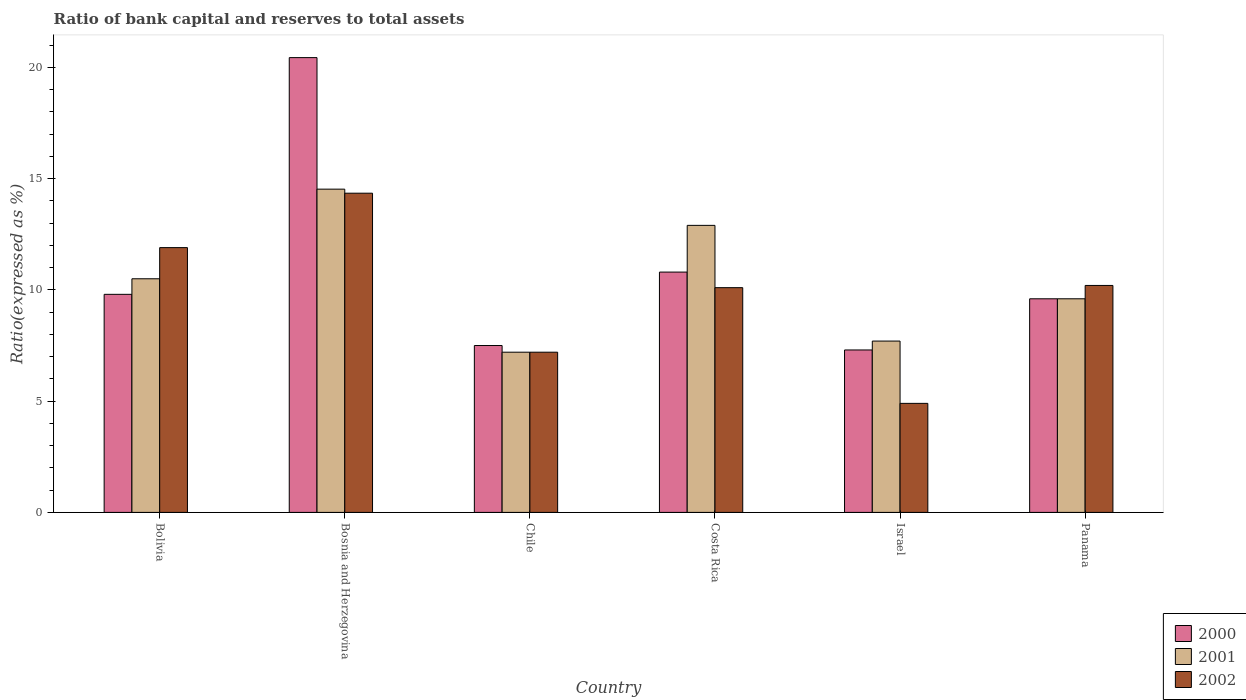How many different coloured bars are there?
Keep it short and to the point. 3. How many groups of bars are there?
Give a very brief answer. 6. Are the number of bars on each tick of the X-axis equal?
Offer a terse response. Yes. How many bars are there on the 1st tick from the left?
Provide a succinct answer. 3. How many bars are there on the 3rd tick from the right?
Offer a very short reply. 3. What is the label of the 6th group of bars from the left?
Your answer should be very brief. Panama. In how many cases, is the number of bars for a given country not equal to the number of legend labels?
Your answer should be compact. 0. What is the ratio of bank capital and reserves to total assets in 2000 in Bosnia and Herzegovina?
Offer a terse response. 20.44. Across all countries, what is the maximum ratio of bank capital and reserves to total assets in 2002?
Offer a very short reply. 14.35. Across all countries, what is the minimum ratio of bank capital and reserves to total assets in 2000?
Give a very brief answer. 7.3. In which country was the ratio of bank capital and reserves to total assets in 2001 maximum?
Offer a very short reply. Bosnia and Herzegovina. In which country was the ratio of bank capital and reserves to total assets in 2002 minimum?
Make the answer very short. Israel. What is the total ratio of bank capital and reserves to total assets in 2001 in the graph?
Offer a terse response. 62.43. What is the difference between the ratio of bank capital and reserves to total assets in 2002 in Bosnia and Herzegovina and that in Israel?
Your response must be concise. 9.45. What is the difference between the ratio of bank capital and reserves to total assets in 2002 in Chile and the ratio of bank capital and reserves to total assets in 2000 in Panama?
Provide a succinct answer. -2.4. What is the average ratio of bank capital and reserves to total assets in 2002 per country?
Your answer should be compact. 9.77. What is the difference between the ratio of bank capital and reserves to total assets of/in 2000 and ratio of bank capital and reserves to total assets of/in 2002 in Bolivia?
Your answer should be compact. -2.1. In how many countries, is the ratio of bank capital and reserves to total assets in 2002 greater than 18 %?
Your answer should be very brief. 0. What is the ratio of the ratio of bank capital and reserves to total assets in 2002 in Israel to that in Panama?
Ensure brevity in your answer.  0.48. Is the difference between the ratio of bank capital and reserves to total assets in 2000 in Bolivia and Chile greater than the difference between the ratio of bank capital and reserves to total assets in 2002 in Bolivia and Chile?
Keep it short and to the point. No. What is the difference between the highest and the second highest ratio of bank capital and reserves to total assets in 2002?
Make the answer very short. -1.7. What is the difference between the highest and the lowest ratio of bank capital and reserves to total assets in 2000?
Offer a very short reply. 13.14. What does the 2nd bar from the left in Bolivia represents?
Make the answer very short. 2001. How many bars are there?
Your answer should be compact. 18. Are all the bars in the graph horizontal?
Provide a short and direct response. No. How many countries are there in the graph?
Your answer should be compact. 6. Are the values on the major ticks of Y-axis written in scientific E-notation?
Your response must be concise. No. Does the graph contain any zero values?
Offer a very short reply. No. Where does the legend appear in the graph?
Provide a succinct answer. Bottom right. How are the legend labels stacked?
Offer a terse response. Vertical. What is the title of the graph?
Provide a short and direct response. Ratio of bank capital and reserves to total assets. Does "1971" appear as one of the legend labels in the graph?
Give a very brief answer. No. What is the label or title of the Y-axis?
Give a very brief answer. Ratio(expressed as %). What is the Ratio(expressed as %) in 2001 in Bolivia?
Keep it short and to the point. 10.5. What is the Ratio(expressed as %) in 2002 in Bolivia?
Your response must be concise. 11.9. What is the Ratio(expressed as %) in 2000 in Bosnia and Herzegovina?
Keep it short and to the point. 20.44. What is the Ratio(expressed as %) of 2001 in Bosnia and Herzegovina?
Give a very brief answer. 14.53. What is the Ratio(expressed as %) of 2002 in Bosnia and Herzegovina?
Keep it short and to the point. 14.35. What is the Ratio(expressed as %) of 2001 in Chile?
Make the answer very short. 7.2. What is the Ratio(expressed as %) of 2000 in Costa Rica?
Offer a terse response. 10.8. What is the Ratio(expressed as %) of 2001 in Costa Rica?
Provide a succinct answer. 12.9. What is the Ratio(expressed as %) of 2000 in Israel?
Ensure brevity in your answer.  7.3. What is the Ratio(expressed as %) in 2002 in Israel?
Ensure brevity in your answer.  4.9. What is the Ratio(expressed as %) in 2000 in Panama?
Offer a very short reply. 9.6. Across all countries, what is the maximum Ratio(expressed as %) in 2000?
Provide a short and direct response. 20.44. Across all countries, what is the maximum Ratio(expressed as %) of 2001?
Provide a short and direct response. 14.53. Across all countries, what is the maximum Ratio(expressed as %) in 2002?
Offer a very short reply. 14.35. Across all countries, what is the minimum Ratio(expressed as %) in 2001?
Provide a succinct answer. 7.2. What is the total Ratio(expressed as %) in 2000 in the graph?
Provide a short and direct response. 65.44. What is the total Ratio(expressed as %) in 2001 in the graph?
Your answer should be compact. 62.43. What is the total Ratio(expressed as %) in 2002 in the graph?
Ensure brevity in your answer.  58.65. What is the difference between the Ratio(expressed as %) in 2000 in Bolivia and that in Bosnia and Herzegovina?
Offer a terse response. -10.64. What is the difference between the Ratio(expressed as %) in 2001 in Bolivia and that in Bosnia and Herzegovina?
Ensure brevity in your answer.  -4.03. What is the difference between the Ratio(expressed as %) in 2002 in Bolivia and that in Bosnia and Herzegovina?
Your answer should be compact. -2.45. What is the difference between the Ratio(expressed as %) of 2001 in Bolivia and that in Chile?
Offer a terse response. 3.3. What is the difference between the Ratio(expressed as %) in 2002 in Bolivia and that in Chile?
Your response must be concise. 4.7. What is the difference between the Ratio(expressed as %) in 2001 in Bolivia and that in Costa Rica?
Provide a short and direct response. -2.4. What is the difference between the Ratio(expressed as %) of 2002 in Bolivia and that in Costa Rica?
Your response must be concise. 1.8. What is the difference between the Ratio(expressed as %) of 2000 in Bolivia and that in Israel?
Your response must be concise. 2.5. What is the difference between the Ratio(expressed as %) in 2001 in Bolivia and that in Israel?
Ensure brevity in your answer.  2.8. What is the difference between the Ratio(expressed as %) of 2001 in Bolivia and that in Panama?
Give a very brief answer. 0.9. What is the difference between the Ratio(expressed as %) of 2000 in Bosnia and Herzegovina and that in Chile?
Your response must be concise. 12.94. What is the difference between the Ratio(expressed as %) of 2001 in Bosnia and Herzegovina and that in Chile?
Keep it short and to the point. 7.33. What is the difference between the Ratio(expressed as %) in 2002 in Bosnia and Herzegovina and that in Chile?
Give a very brief answer. 7.15. What is the difference between the Ratio(expressed as %) in 2000 in Bosnia and Herzegovina and that in Costa Rica?
Your response must be concise. 9.64. What is the difference between the Ratio(expressed as %) of 2001 in Bosnia and Herzegovina and that in Costa Rica?
Ensure brevity in your answer.  1.63. What is the difference between the Ratio(expressed as %) of 2002 in Bosnia and Herzegovina and that in Costa Rica?
Provide a short and direct response. 4.25. What is the difference between the Ratio(expressed as %) of 2000 in Bosnia and Herzegovina and that in Israel?
Give a very brief answer. 13.14. What is the difference between the Ratio(expressed as %) of 2001 in Bosnia and Herzegovina and that in Israel?
Offer a very short reply. 6.83. What is the difference between the Ratio(expressed as %) in 2002 in Bosnia and Herzegovina and that in Israel?
Make the answer very short. 9.45. What is the difference between the Ratio(expressed as %) of 2000 in Bosnia and Herzegovina and that in Panama?
Make the answer very short. 10.84. What is the difference between the Ratio(expressed as %) of 2001 in Bosnia and Herzegovina and that in Panama?
Ensure brevity in your answer.  4.93. What is the difference between the Ratio(expressed as %) in 2002 in Bosnia and Herzegovina and that in Panama?
Offer a very short reply. 4.15. What is the difference between the Ratio(expressed as %) of 2000 in Chile and that in Costa Rica?
Give a very brief answer. -3.3. What is the difference between the Ratio(expressed as %) of 2002 in Chile and that in Costa Rica?
Give a very brief answer. -2.9. What is the difference between the Ratio(expressed as %) of 2000 in Chile and that in Israel?
Your answer should be compact. 0.2. What is the difference between the Ratio(expressed as %) in 2002 in Costa Rica and that in Israel?
Give a very brief answer. 5.2. What is the difference between the Ratio(expressed as %) in 2000 in Costa Rica and that in Panama?
Make the answer very short. 1.2. What is the difference between the Ratio(expressed as %) of 2000 in Israel and that in Panama?
Your answer should be very brief. -2.3. What is the difference between the Ratio(expressed as %) in 2001 in Israel and that in Panama?
Provide a succinct answer. -1.9. What is the difference between the Ratio(expressed as %) of 2000 in Bolivia and the Ratio(expressed as %) of 2001 in Bosnia and Herzegovina?
Offer a terse response. -4.73. What is the difference between the Ratio(expressed as %) in 2000 in Bolivia and the Ratio(expressed as %) in 2002 in Bosnia and Herzegovina?
Your answer should be compact. -4.55. What is the difference between the Ratio(expressed as %) in 2001 in Bolivia and the Ratio(expressed as %) in 2002 in Bosnia and Herzegovina?
Provide a short and direct response. -3.85. What is the difference between the Ratio(expressed as %) in 2001 in Bolivia and the Ratio(expressed as %) in 2002 in Chile?
Your response must be concise. 3.3. What is the difference between the Ratio(expressed as %) in 2000 in Bolivia and the Ratio(expressed as %) in 2001 in Costa Rica?
Give a very brief answer. -3.1. What is the difference between the Ratio(expressed as %) of 2000 in Bolivia and the Ratio(expressed as %) of 2002 in Costa Rica?
Offer a very short reply. -0.3. What is the difference between the Ratio(expressed as %) of 2001 in Bolivia and the Ratio(expressed as %) of 2002 in Costa Rica?
Ensure brevity in your answer.  0.4. What is the difference between the Ratio(expressed as %) of 2000 in Bolivia and the Ratio(expressed as %) of 2002 in Panama?
Provide a succinct answer. -0.4. What is the difference between the Ratio(expressed as %) in 2001 in Bolivia and the Ratio(expressed as %) in 2002 in Panama?
Ensure brevity in your answer.  0.3. What is the difference between the Ratio(expressed as %) in 2000 in Bosnia and Herzegovina and the Ratio(expressed as %) in 2001 in Chile?
Provide a succinct answer. 13.24. What is the difference between the Ratio(expressed as %) of 2000 in Bosnia and Herzegovina and the Ratio(expressed as %) of 2002 in Chile?
Make the answer very short. 13.24. What is the difference between the Ratio(expressed as %) in 2001 in Bosnia and Herzegovina and the Ratio(expressed as %) in 2002 in Chile?
Provide a succinct answer. 7.33. What is the difference between the Ratio(expressed as %) of 2000 in Bosnia and Herzegovina and the Ratio(expressed as %) of 2001 in Costa Rica?
Offer a terse response. 7.54. What is the difference between the Ratio(expressed as %) in 2000 in Bosnia and Herzegovina and the Ratio(expressed as %) in 2002 in Costa Rica?
Give a very brief answer. 10.34. What is the difference between the Ratio(expressed as %) in 2001 in Bosnia and Herzegovina and the Ratio(expressed as %) in 2002 in Costa Rica?
Make the answer very short. 4.43. What is the difference between the Ratio(expressed as %) of 2000 in Bosnia and Herzegovina and the Ratio(expressed as %) of 2001 in Israel?
Provide a short and direct response. 12.74. What is the difference between the Ratio(expressed as %) of 2000 in Bosnia and Herzegovina and the Ratio(expressed as %) of 2002 in Israel?
Offer a terse response. 15.54. What is the difference between the Ratio(expressed as %) in 2001 in Bosnia and Herzegovina and the Ratio(expressed as %) in 2002 in Israel?
Ensure brevity in your answer.  9.63. What is the difference between the Ratio(expressed as %) in 2000 in Bosnia and Herzegovina and the Ratio(expressed as %) in 2001 in Panama?
Your answer should be very brief. 10.84. What is the difference between the Ratio(expressed as %) of 2000 in Bosnia and Herzegovina and the Ratio(expressed as %) of 2002 in Panama?
Give a very brief answer. 10.24. What is the difference between the Ratio(expressed as %) of 2001 in Bosnia and Herzegovina and the Ratio(expressed as %) of 2002 in Panama?
Offer a terse response. 4.33. What is the difference between the Ratio(expressed as %) in 2000 in Chile and the Ratio(expressed as %) in 2002 in Costa Rica?
Offer a terse response. -2.6. What is the difference between the Ratio(expressed as %) of 2001 in Chile and the Ratio(expressed as %) of 2002 in Costa Rica?
Your answer should be very brief. -2.9. What is the difference between the Ratio(expressed as %) of 2000 in Chile and the Ratio(expressed as %) of 2001 in Israel?
Give a very brief answer. -0.2. What is the difference between the Ratio(expressed as %) in 2000 in Chile and the Ratio(expressed as %) in 2002 in Israel?
Give a very brief answer. 2.6. What is the difference between the Ratio(expressed as %) in 2001 in Chile and the Ratio(expressed as %) in 2002 in Israel?
Your response must be concise. 2.3. What is the difference between the Ratio(expressed as %) of 2000 in Chile and the Ratio(expressed as %) of 2002 in Panama?
Your response must be concise. -2.7. What is the difference between the Ratio(expressed as %) of 2001 in Chile and the Ratio(expressed as %) of 2002 in Panama?
Give a very brief answer. -3. What is the difference between the Ratio(expressed as %) of 2000 in Costa Rica and the Ratio(expressed as %) of 2001 in Israel?
Provide a short and direct response. 3.1. What is the difference between the Ratio(expressed as %) in 2001 in Costa Rica and the Ratio(expressed as %) in 2002 in Israel?
Keep it short and to the point. 8. What is the difference between the Ratio(expressed as %) of 2001 in Costa Rica and the Ratio(expressed as %) of 2002 in Panama?
Provide a succinct answer. 2.7. What is the difference between the Ratio(expressed as %) of 2000 in Israel and the Ratio(expressed as %) of 2001 in Panama?
Provide a succinct answer. -2.3. What is the average Ratio(expressed as %) of 2000 per country?
Make the answer very short. 10.91. What is the average Ratio(expressed as %) of 2001 per country?
Make the answer very short. 10.4. What is the average Ratio(expressed as %) of 2002 per country?
Ensure brevity in your answer.  9.77. What is the difference between the Ratio(expressed as %) of 2000 and Ratio(expressed as %) of 2001 in Bolivia?
Offer a very short reply. -0.7. What is the difference between the Ratio(expressed as %) of 2000 and Ratio(expressed as %) of 2001 in Bosnia and Herzegovina?
Your answer should be very brief. 5.91. What is the difference between the Ratio(expressed as %) of 2000 and Ratio(expressed as %) of 2002 in Bosnia and Herzegovina?
Ensure brevity in your answer.  6.09. What is the difference between the Ratio(expressed as %) in 2001 and Ratio(expressed as %) in 2002 in Bosnia and Herzegovina?
Your response must be concise. 0.18. What is the difference between the Ratio(expressed as %) in 2000 and Ratio(expressed as %) in 2001 in Chile?
Keep it short and to the point. 0.3. What is the difference between the Ratio(expressed as %) of 2000 and Ratio(expressed as %) of 2002 in Chile?
Your answer should be very brief. 0.3. What is the difference between the Ratio(expressed as %) of 2000 and Ratio(expressed as %) of 2002 in Costa Rica?
Provide a short and direct response. 0.7. What is the difference between the Ratio(expressed as %) of 2000 and Ratio(expressed as %) of 2001 in Israel?
Keep it short and to the point. -0.4. What is the difference between the Ratio(expressed as %) in 2000 and Ratio(expressed as %) in 2002 in Israel?
Your answer should be very brief. 2.4. What is the difference between the Ratio(expressed as %) of 2000 and Ratio(expressed as %) of 2001 in Panama?
Make the answer very short. 0. What is the difference between the Ratio(expressed as %) in 2000 and Ratio(expressed as %) in 2002 in Panama?
Give a very brief answer. -0.6. What is the difference between the Ratio(expressed as %) of 2001 and Ratio(expressed as %) of 2002 in Panama?
Offer a very short reply. -0.6. What is the ratio of the Ratio(expressed as %) in 2000 in Bolivia to that in Bosnia and Herzegovina?
Your answer should be compact. 0.48. What is the ratio of the Ratio(expressed as %) in 2001 in Bolivia to that in Bosnia and Herzegovina?
Provide a short and direct response. 0.72. What is the ratio of the Ratio(expressed as %) of 2002 in Bolivia to that in Bosnia and Herzegovina?
Give a very brief answer. 0.83. What is the ratio of the Ratio(expressed as %) of 2000 in Bolivia to that in Chile?
Make the answer very short. 1.31. What is the ratio of the Ratio(expressed as %) in 2001 in Bolivia to that in Chile?
Offer a terse response. 1.46. What is the ratio of the Ratio(expressed as %) of 2002 in Bolivia to that in Chile?
Your answer should be very brief. 1.65. What is the ratio of the Ratio(expressed as %) of 2000 in Bolivia to that in Costa Rica?
Your answer should be compact. 0.91. What is the ratio of the Ratio(expressed as %) in 2001 in Bolivia to that in Costa Rica?
Give a very brief answer. 0.81. What is the ratio of the Ratio(expressed as %) in 2002 in Bolivia to that in Costa Rica?
Your response must be concise. 1.18. What is the ratio of the Ratio(expressed as %) of 2000 in Bolivia to that in Israel?
Keep it short and to the point. 1.34. What is the ratio of the Ratio(expressed as %) in 2001 in Bolivia to that in Israel?
Provide a succinct answer. 1.36. What is the ratio of the Ratio(expressed as %) of 2002 in Bolivia to that in Israel?
Your response must be concise. 2.43. What is the ratio of the Ratio(expressed as %) in 2000 in Bolivia to that in Panama?
Keep it short and to the point. 1.02. What is the ratio of the Ratio(expressed as %) of 2001 in Bolivia to that in Panama?
Ensure brevity in your answer.  1.09. What is the ratio of the Ratio(expressed as %) in 2000 in Bosnia and Herzegovina to that in Chile?
Give a very brief answer. 2.73. What is the ratio of the Ratio(expressed as %) of 2001 in Bosnia and Herzegovina to that in Chile?
Offer a very short reply. 2.02. What is the ratio of the Ratio(expressed as %) of 2002 in Bosnia and Herzegovina to that in Chile?
Give a very brief answer. 1.99. What is the ratio of the Ratio(expressed as %) in 2000 in Bosnia and Herzegovina to that in Costa Rica?
Ensure brevity in your answer.  1.89. What is the ratio of the Ratio(expressed as %) of 2001 in Bosnia and Herzegovina to that in Costa Rica?
Ensure brevity in your answer.  1.13. What is the ratio of the Ratio(expressed as %) of 2002 in Bosnia and Herzegovina to that in Costa Rica?
Offer a very short reply. 1.42. What is the ratio of the Ratio(expressed as %) in 2000 in Bosnia and Herzegovina to that in Israel?
Ensure brevity in your answer.  2.8. What is the ratio of the Ratio(expressed as %) of 2001 in Bosnia and Herzegovina to that in Israel?
Give a very brief answer. 1.89. What is the ratio of the Ratio(expressed as %) in 2002 in Bosnia and Herzegovina to that in Israel?
Keep it short and to the point. 2.93. What is the ratio of the Ratio(expressed as %) in 2000 in Bosnia and Herzegovina to that in Panama?
Ensure brevity in your answer.  2.13. What is the ratio of the Ratio(expressed as %) of 2001 in Bosnia and Herzegovina to that in Panama?
Your answer should be very brief. 1.51. What is the ratio of the Ratio(expressed as %) in 2002 in Bosnia and Herzegovina to that in Panama?
Give a very brief answer. 1.41. What is the ratio of the Ratio(expressed as %) of 2000 in Chile to that in Costa Rica?
Provide a succinct answer. 0.69. What is the ratio of the Ratio(expressed as %) of 2001 in Chile to that in Costa Rica?
Provide a short and direct response. 0.56. What is the ratio of the Ratio(expressed as %) of 2002 in Chile to that in Costa Rica?
Your answer should be compact. 0.71. What is the ratio of the Ratio(expressed as %) in 2000 in Chile to that in Israel?
Your answer should be very brief. 1.03. What is the ratio of the Ratio(expressed as %) of 2001 in Chile to that in Israel?
Offer a terse response. 0.94. What is the ratio of the Ratio(expressed as %) in 2002 in Chile to that in Israel?
Give a very brief answer. 1.47. What is the ratio of the Ratio(expressed as %) in 2000 in Chile to that in Panama?
Provide a short and direct response. 0.78. What is the ratio of the Ratio(expressed as %) of 2002 in Chile to that in Panama?
Offer a very short reply. 0.71. What is the ratio of the Ratio(expressed as %) of 2000 in Costa Rica to that in Israel?
Provide a succinct answer. 1.48. What is the ratio of the Ratio(expressed as %) in 2001 in Costa Rica to that in Israel?
Offer a very short reply. 1.68. What is the ratio of the Ratio(expressed as %) of 2002 in Costa Rica to that in Israel?
Make the answer very short. 2.06. What is the ratio of the Ratio(expressed as %) in 2001 in Costa Rica to that in Panama?
Your answer should be compact. 1.34. What is the ratio of the Ratio(expressed as %) of 2002 in Costa Rica to that in Panama?
Your answer should be compact. 0.99. What is the ratio of the Ratio(expressed as %) in 2000 in Israel to that in Panama?
Give a very brief answer. 0.76. What is the ratio of the Ratio(expressed as %) in 2001 in Israel to that in Panama?
Offer a very short reply. 0.8. What is the ratio of the Ratio(expressed as %) of 2002 in Israel to that in Panama?
Give a very brief answer. 0.48. What is the difference between the highest and the second highest Ratio(expressed as %) in 2000?
Keep it short and to the point. 9.64. What is the difference between the highest and the second highest Ratio(expressed as %) in 2001?
Provide a short and direct response. 1.63. What is the difference between the highest and the second highest Ratio(expressed as %) in 2002?
Offer a terse response. 2.45. What is the difference between the highest and the lowest Ratio(expressed as %) of 2000?
Offer a terse response. 13.14. What is the difference between the highest and the lowest Ratio(expressed as %) of 2001?
Offer a terse response. 7.33. What is the difference between the highest and the lowest Ratio(expressed as %) in 2002?
Offer a terse response. 9.45. 